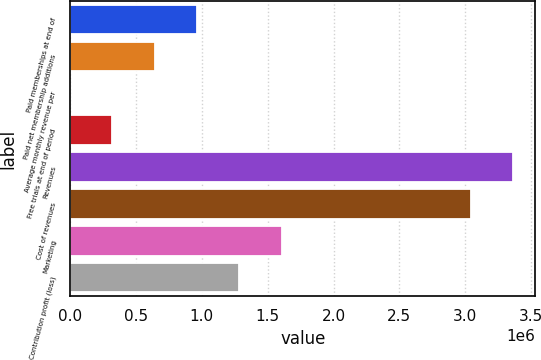Convert chart. <chart><loc_0><loc_0><loc_500><loc_500><bar_chart><fcel>Paid memberships at end of<fcel>Paid net membership additions<fcel>Average monthly revenue per<fcel>Free trials at end of period<fcel>Revenues<fcel>Cost of revenues<fcel>Marketing<fcel>Contribution profit (loss)<nl><fcel>963334<fcel>642225<fcel>7.81<fcel>321117<fcel>3.36386e+06<fcel>3.04275e+06<fcel>1.60555e+06<fcel>1.28444e+06<nl></chart> 